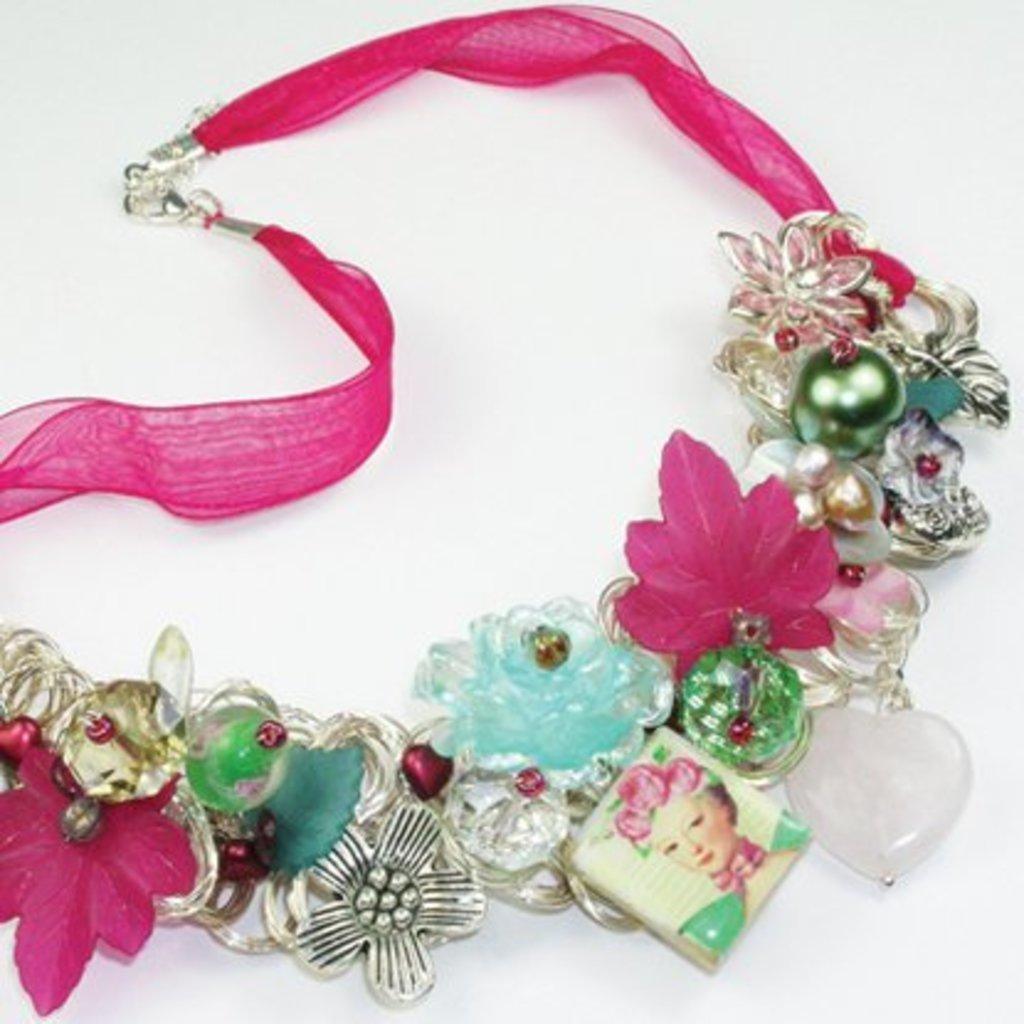What type of jewelry is present in the image? There is a necklace in the image. What is the necklace made of? The necklace is made up of a pink color ribbon. On what surface is the necklace placed? The necklace is placed on a white surface. What sign is the son holding in the image? There is no son or sign present in the image; it only features a necklace on a white surface. 